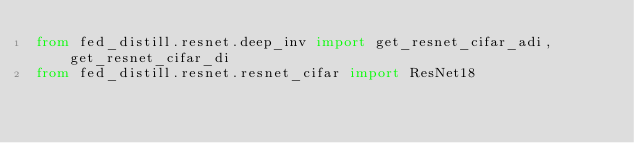<code> <loc_0><loc_0><loc_500><loc_500><_Python_>from fed_distill.resnet.deep_inv import get_resnet_cifar_adi, get_resnet_cifar_di
from fed_distill.resnet.resnet_cifar import ResNet18
</code> 